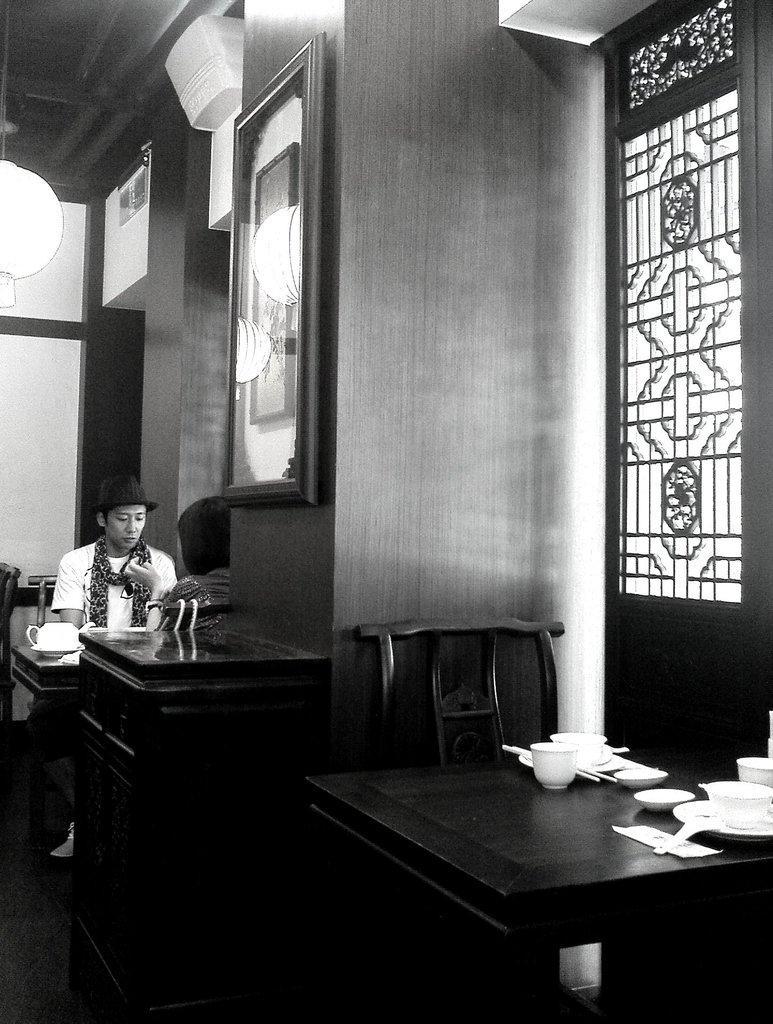In one or two sentences, can you explain what this image depicts? This picture is clicked inside the room. On the right there is a table on that there is a cup and saucer. On the left there are two people. In the background there is a window, frame and light. 